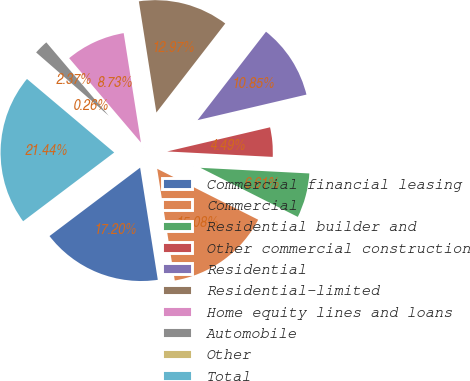Convert chart to OTSL. <chart><loc_0><loc_0><loc_500><loc_500><pie_chart><fcel>Commercial financial leasing<fcel>Commercial<fcel>Residential builder and<fcel>Other commercial construction<fcel>Residential<fcel>Residential-limited<fcel>Home equity lines and loans<fcel>Automobile<fcel>Other<fcel>Total<nl><fcel>17.2%<fcel>15.08%<fcel>6.61%<fcel>4.49%<fcel>10.85%<fcel>12.97%<fcel>8.73%<fcel>2.37%<fcel>0.26%<fcel>21.44%<nl></chart> 